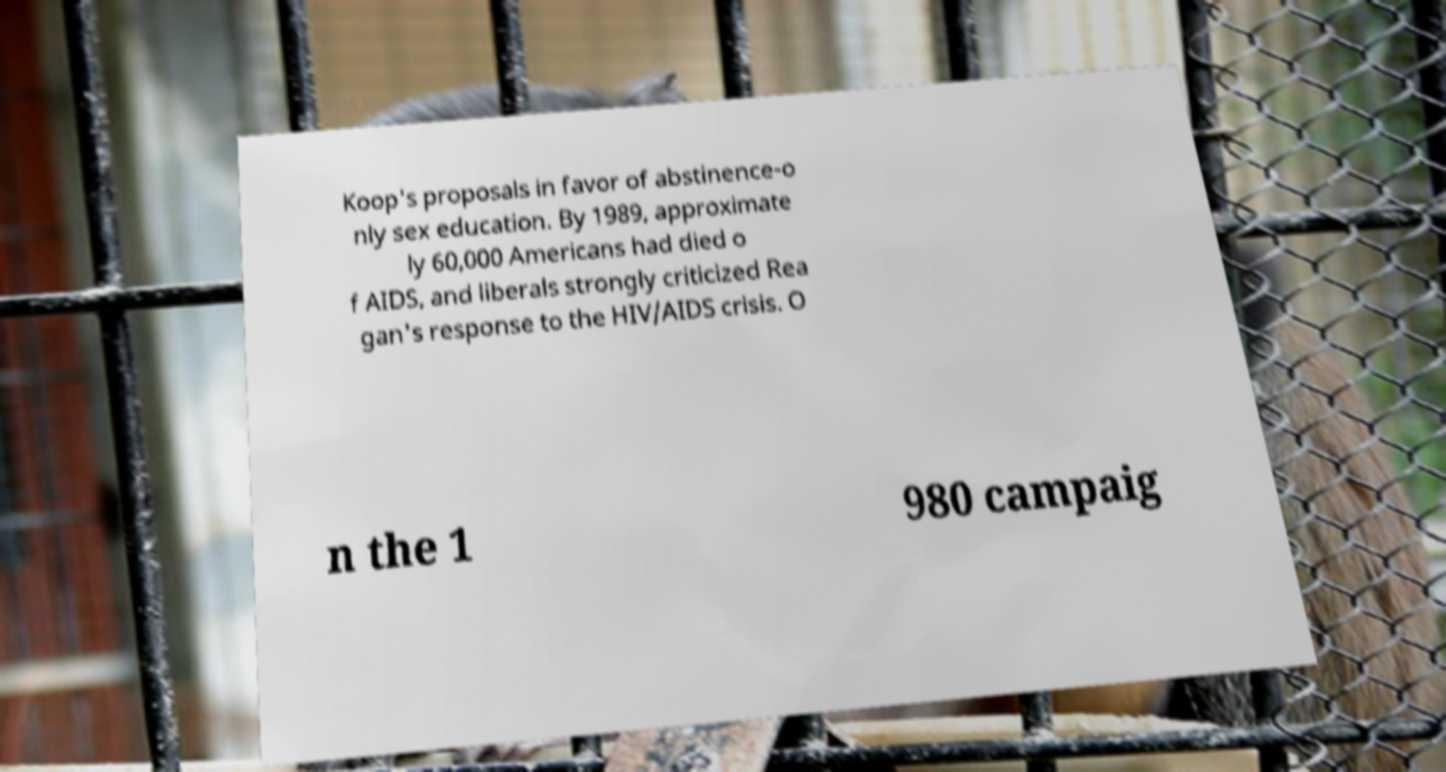Please identify and transcribe the text found in this image. Koop's proposals in favor of abstinence-o nly sex education. By 1989, approximate ly 60,000 Americans had died o f AIDS, and liberals strongly criticized Rea gan's response to the HIV/AIDS crisis. O n the 1 980 campaig 